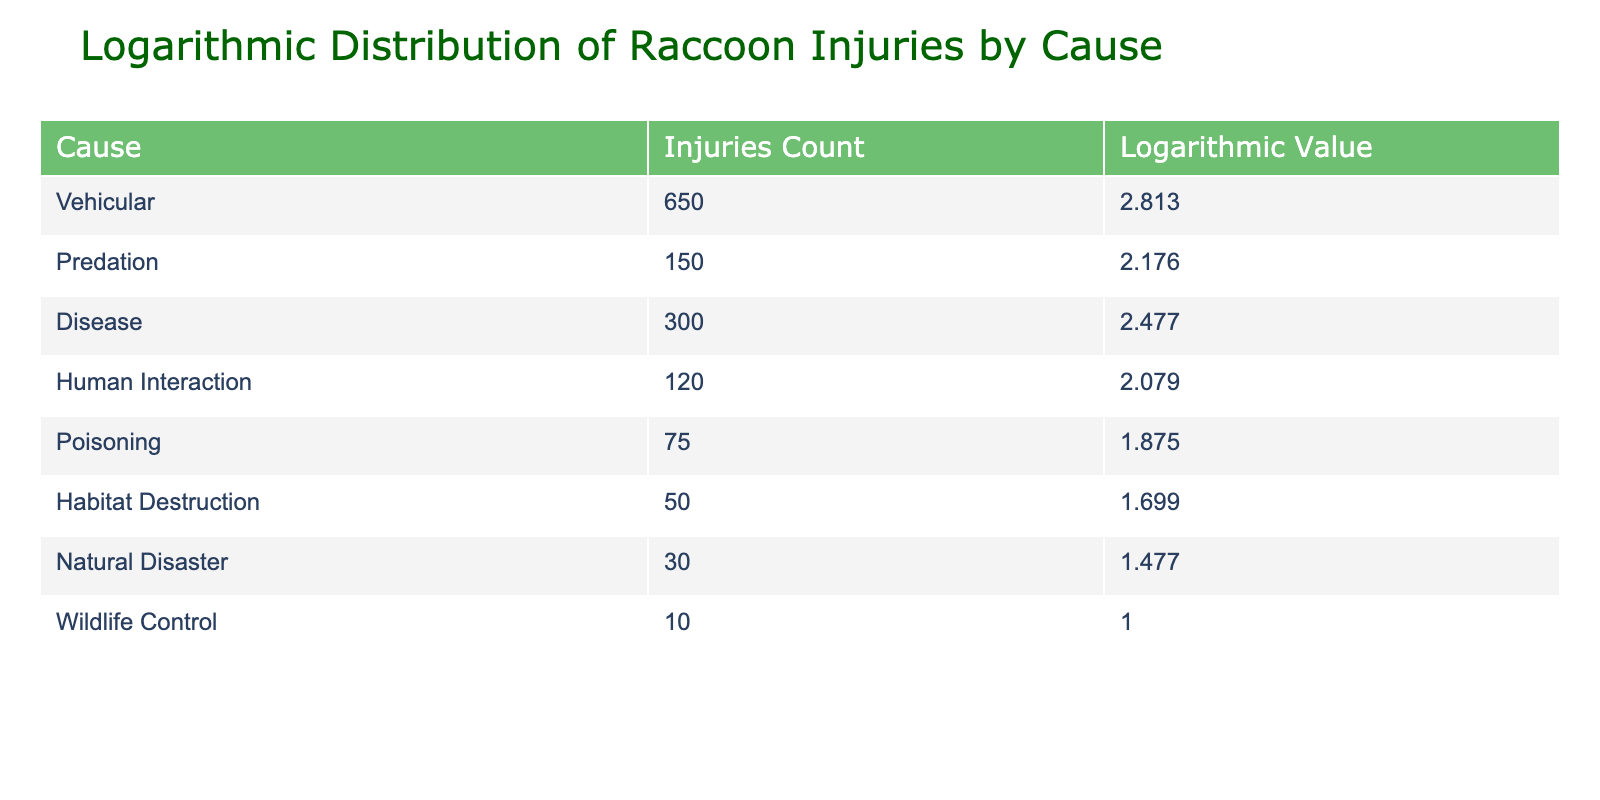What is the highest number of injuries recorded for a single cause? The table shows that the highest number of injuries recorded is 650 for the cause "Vehicular." This can be directly observed from the "Injuries Count" column.
Answer: 650 What is the logarithmic value for "Poisoning"? From the table, "Poisoning" has a logarithmic value of 1.875, which can be found in the "Logarithmic Value" column corresponding to this cause.
Answer: 1.875 How many injuries are due to "Human Interaction" and "Poisoning" combined? The number of injuries for "Human Interaction" is 120 and for "Poisoning" is 75. By adding these two values together: 120 + 75 = 195. Hence, the total is 195.
Answer: 195 Is the number of injuries from "Natural Disaster" greater than that from "Wildlife Control"? The number of injuries from "Natural Disaster" is 30, and for "Wildlife Control," it is 10. Since 30 is greater than 10, the answer is true.
Answer: Yes What is the average number of injuries from all causes listed? To find the average, we first sum up all the injuries: 650 + 150 + 300 + 120 + 75 + 50 + 30 + 10 = 1,385. There are 8 causes, so the average is calculated as 1,385 ÷ 8 = 173.125.
Answer: 173.125 Which cause has the lowest logarithmic value? The cause with the lowest logarithmic value is "Wildlife Control," which has a logarithmic value of 1.000. This information is simply readable from the "Logarithmic Value" column.
Answer: 1.000 How many causes have logarithmic values above 2.0? Looking at the logarithmic values, three causes, namely "Vehicular" (2.813), "Disease" (2.477), and "Predation" (2.176), are above 2.0. Therefore, there are 3 causes above this value.
Answer: 3 What is the difference in injury counts between "Vehicular" and "Disease"? The counts are 650 for "Vehicular" and 300 for "Disease." The difference is calculated by subtracting the lower count from the higher count: 650 - 300 = 350.
Answer: 350 